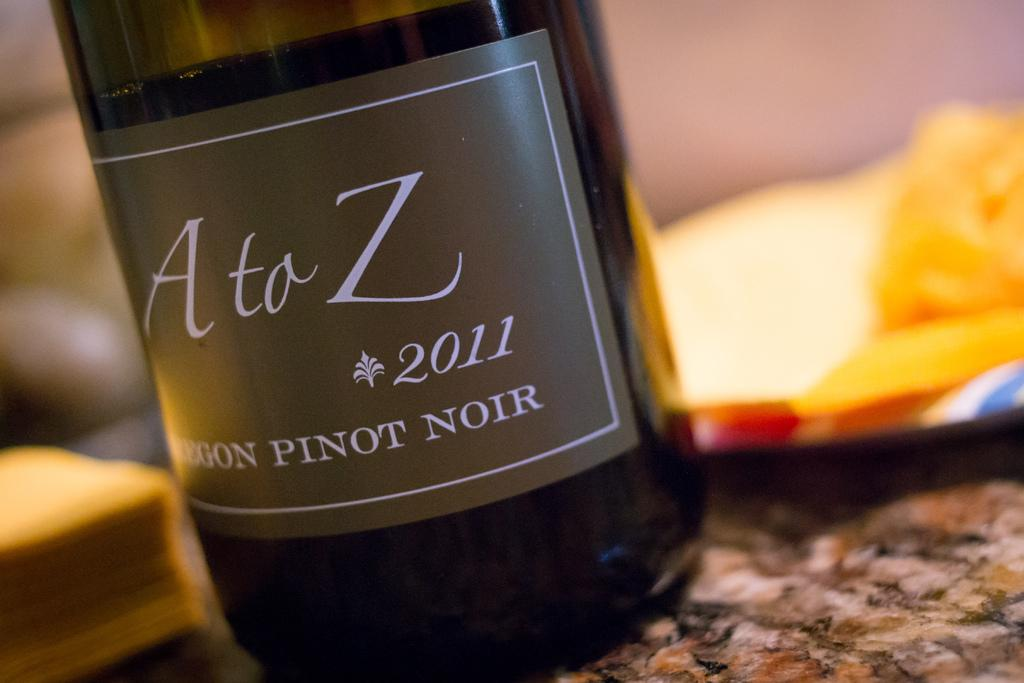<image>
Render a clear and concise summary of the photo. A bottle of A to Z pinot noir is from 2011 